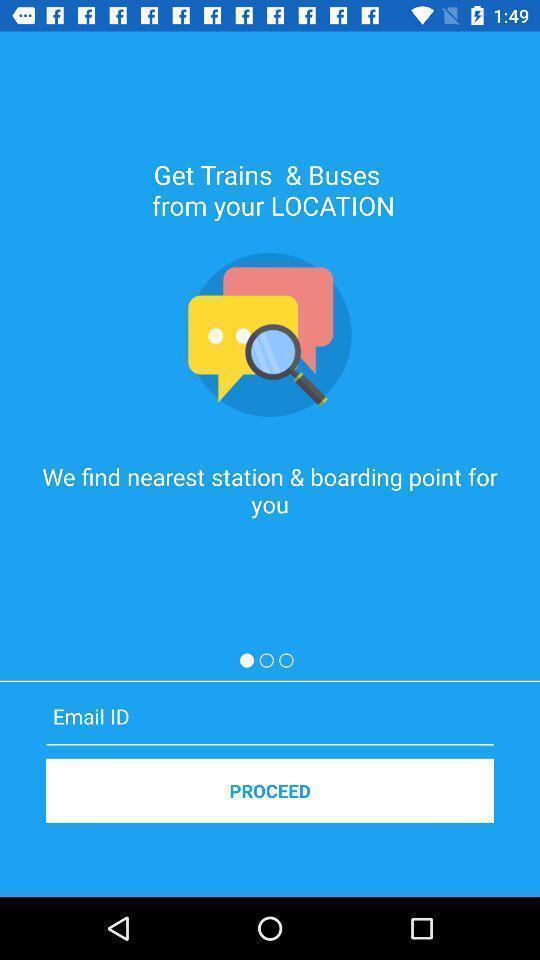Summarize the information in this screenshot. Welcome page of travel app. 